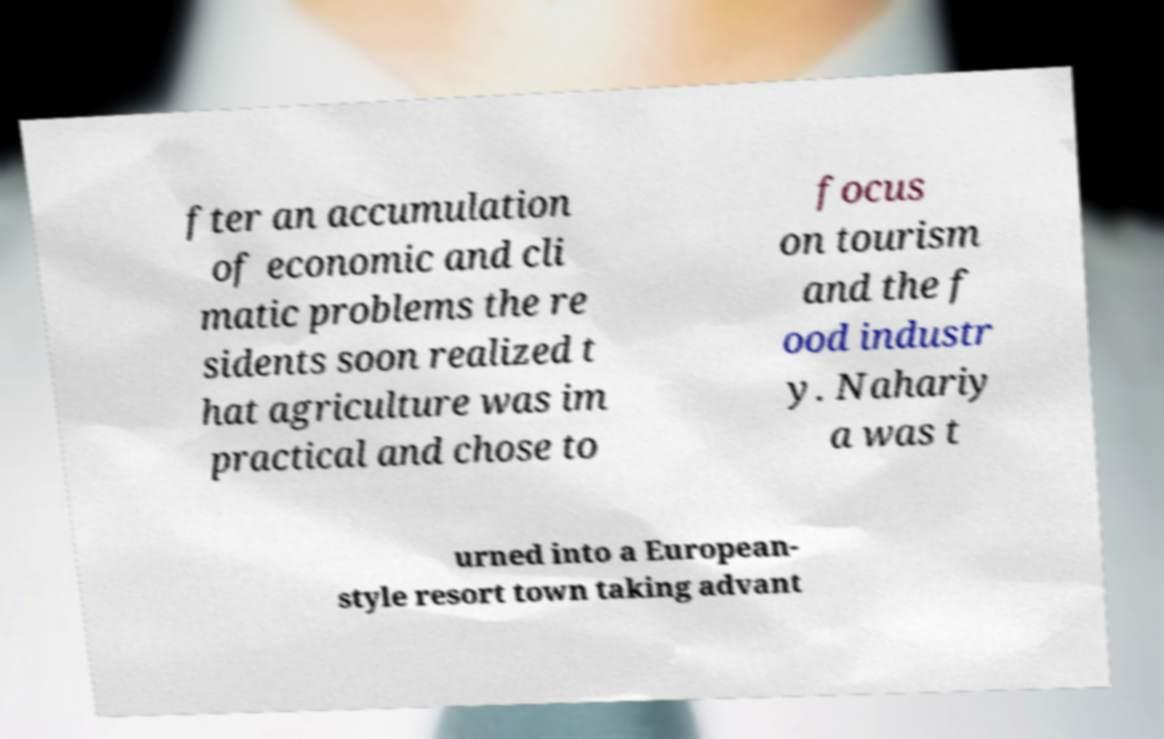What messages or text are displayed in this image? I need them in a readable, typed format. fter an accumulation of economic and cli matic problems the re sidents soon realized t hat agriculture was im practical and chose to focus on tourism and the f ood industr y. Nahariy a was t urned into a European- style resort town taking advant 